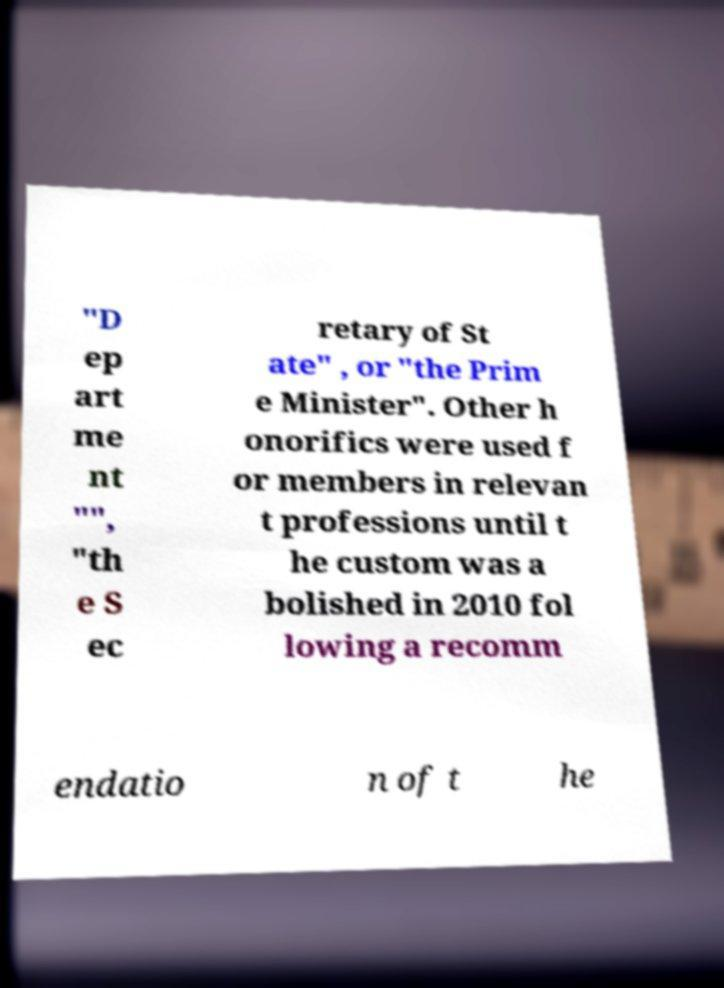Please identify and transcribe the text found in this image. "D ep art me nt "", "th e S ec retary of St ate" , or "the Prim e Minister". Other h onorifics were used f or members in relevan t professions until t he custom was a bolished in 2010 fol lowing a recomm endatio n of t he 